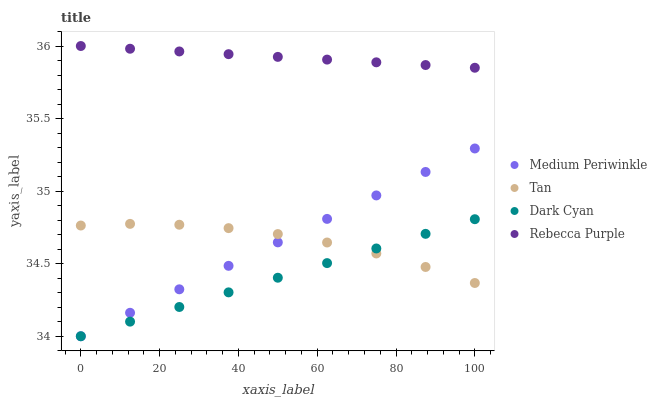Does Dark Cyan have the minimum area under the curve?
Answer yes or no. Yes. Does Rebecca Purple have the maximum area under the curve?
Answer yes or no. Yes. Does Tan have the minimum area under the curve?
Answer yes or no. No. Does Tan have the maximum area under the curve?
Answer yes or no. No. Is Dark Cyan the smoothest?
Answer yes or no. Yes. Is Tan the roughest?
Answer yes or no. Yes. Is Medium Periwinkle the smoothest?
Answer yes or no. No. Is Medium Periwinkle the roughest?
Answer yes or no. No. Does Dark Cyan have the lowest value?
Answer yes or no. Yes. Does Tan have the lowest value?
Answer yes or no. No. Does Rebecca Purple have the highest value?
Answer yes or no. Yes. Does Medium Periwinkle have the highest value?
Answer yes or no. No. Is Medium Periwinkle less than Rebecca Purple?
Answer yes or no. Yes. Is Rebecca Purple greater than Dark Cyan?
Answer yes or no. Yes. Does Tan intersect Dark Cyan?
Answer yes or no. Yes. Is Tan less than Dark Cyan?
Answer yes or no. No. Is Tan greater than Dark Cyan?
Answer yes or no. No. Does Medium Periwinkle intersect Rebecca Purple?
Answer yes or no. No. 